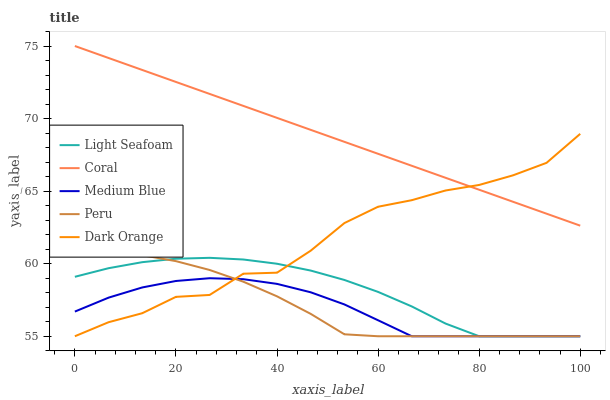Does Medium Blue have the minimum area under the curve?
Answer yes or no. Yes. Does Coral have the maximum area under the curve?
Answer yes or no. Yes. Does Light Seafoam have the minimum area under the curve?
Answer yes or no. No. Does Light Seafoam have the maximum area under the curve?
Answer yes or no. No. Is Coral the smoothest?
Answer yes or no. Yes. Is Dark Orange the roughest?
Answer yes or no. Yes. Is Light Seafoam the smoothest?
Answer yes or no. No. Is Light Seafoam the roughest?
Answer yes or no. No. Does Dark Orange have the lowest value?
Answer yes or no. Yes. Does Coral have the lowest value?
Answer yes or no. No. Does Coral have the highest value?
Answer yes or no. Yes. Does Light Seafoam have the highest value?
Answer yes or no. No. Is Medium Blue less than Coral?
Answer yes or no. Yes. Is Coral greater than Medium Blue?
Answer yes or no. Yes. Does Dark Orange intersect Light Seafoam?
Answer yes or no. Yes. Is Dark Orange less than Light Seafoam?
Answer yes or no. No. Is Dark Orange greater than Light Seafoam?
Answer yes or no. No. Does Medium Blue intersect Coral?
Answer yes or no. No. 